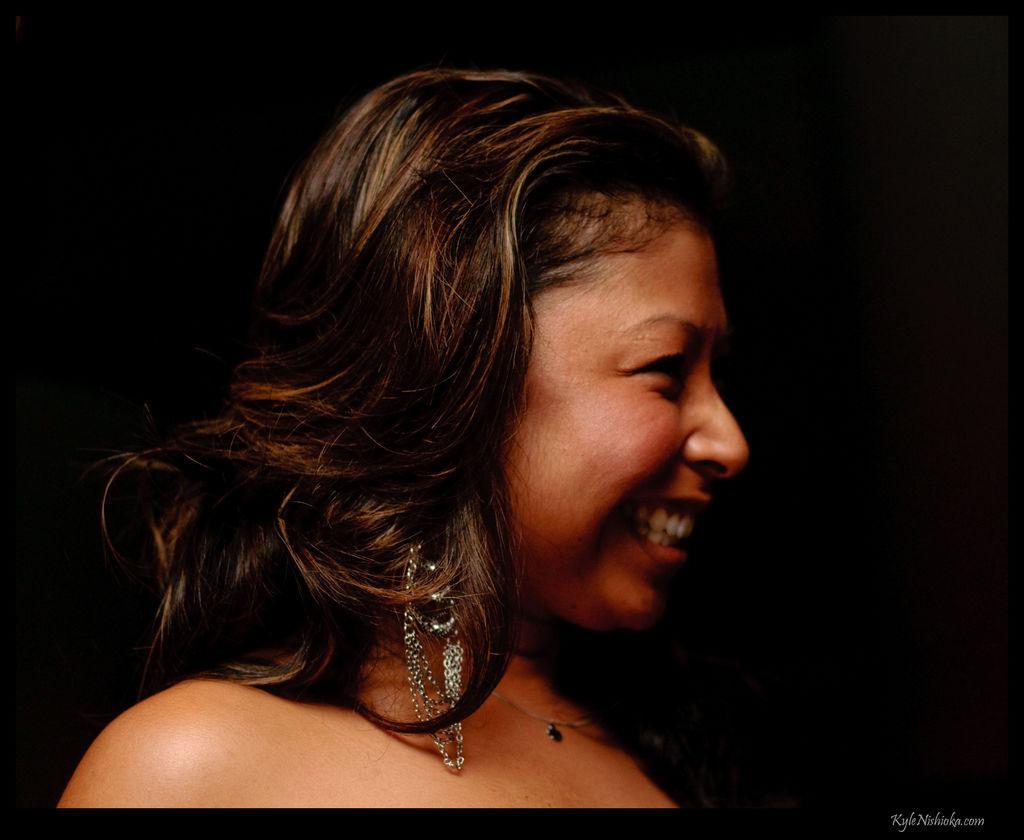Please provide a concise description of this image. In the foreground of this image, there is a woman and the background image is dark. 